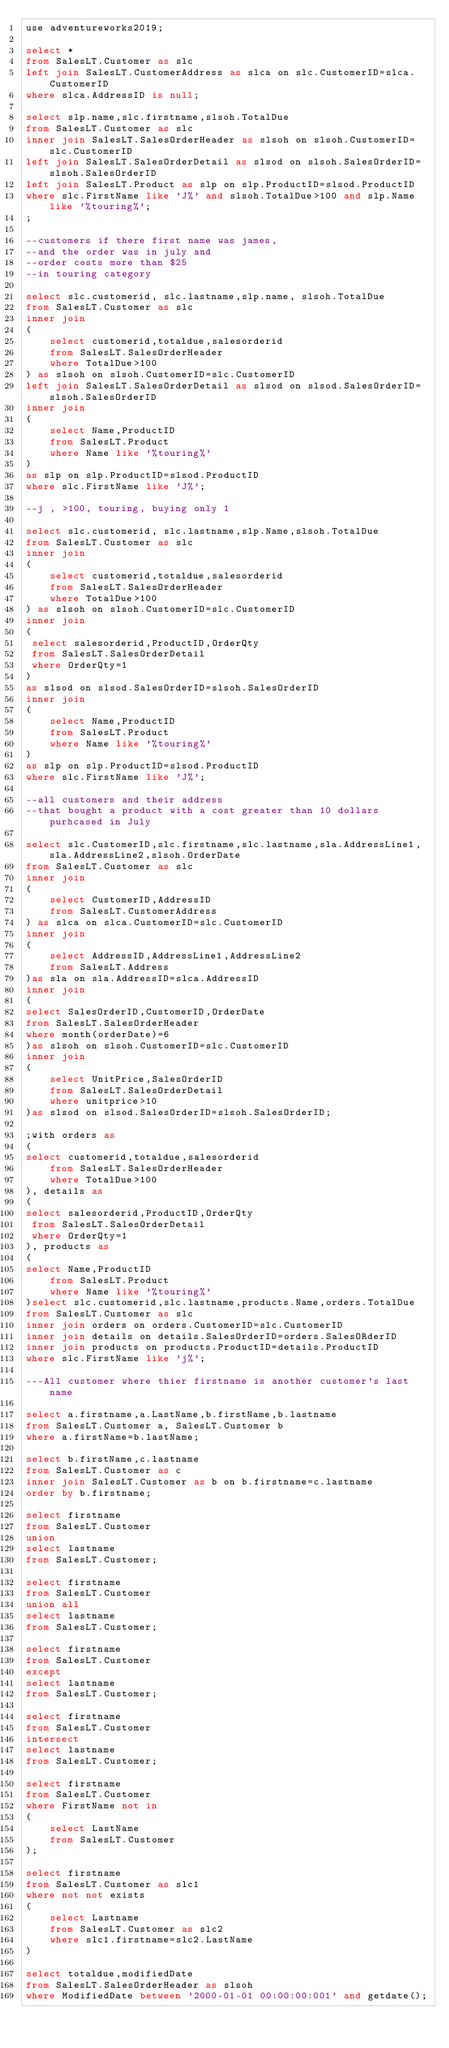Convert code to text. <code><loc_0><loc_0><loc_500><loc_500><_SQL_>use adventureworks2019;

select *
from SalesLT.Customer as slc
left join SalesLT.CustomerAddress as slca on slc.CustomerID=slca.CustomerID
where slca.AddressID is null;

select slp.name,slc.firstname,slsoh.TotalDue
from SalesLT.Customer as slc
inner join SalesLT.SalesOrderHeader as slsoh on slsoh.CustomerID=slc.CustomerID
left join SalesLT.SalesOrderDetail as slsod on slsoh.SalesOrderID=slsoh.SalesOrderID
left join SalesLT.Product as slp on slp.ProductID=slsod.ProductID
where slc.FirstName like 'J%' and slsoh.TotalDue>100 and slp.Name like '%touring%';
;

--customers if there first name was james,
--and the order was in july and 
--order costs more than $25
--in touring category

select slc.customerid, slc.lastname,slp.name, slsoh.TotalDue
from SalesLT.Customer as slc
inner join
(
	select customerid,totaldue,salesorderid
	from SalesLT.SalesOrderHeader
	where TotalDue>100
) as slsoh on slsoh.CustomerID=slc.CustomerID
left join SalesLT.SalesOrderDetail as slsod on slsod.SalesOrderID=slsoh.SalesOrderID
inner join
(
	select Name,ProductID
	from SalesLT.Product
	where Name like '%touring%'
)
as slp on slp.ProductID=slsod.ProductID
where slc.FirstName like 'J%';

--j , >100, touring, buying only 1

select slc.customerid, slc.lastname,slp.Name,slsoh.TotalDue
from SalesLT.Customer as slc
inner join
(
	select customerid,totaldue,salesorderid
	from SalesLT.SalesOrderHeader
	where TotalDue>100
) as slsoh on slsoh.CustomerID=slc.CustomerID
inner join
(
 select salesorderid,ProductID,OrderQty
 from SalesLT.SalesOrderDetail
 where OrderQty=1 
) 
as slsod on slsod.SalesOrderID=slsoh.SalesOrderID
inner join
(
	select Name,ProductID
	from SalesLT.Product
	where Name like '%touring%'
)
as slp on slp.ProductID=slsod.ProductID
where slc.FirstName like 'J%';

--all customers and their address
--that bought a product with a cost greater than 10 dollars purhcased in July

select slc.CustomerID,slc.firstname,slc.lastname,sla.AddressLine1,sla.AddressLine2,slsoh.OrderDate
from SalesLT.Customer as slc
inner join
(
	select CustomerID,AddressID
	from SalesLT.CustomerAddress 
) as slca on slca.CustomerID=slc.CustomerID
inner join
(
	select AddressID,AddressLine1,AddressLine2
	from SalesLT.Address
)as sla on sla.AddressID=slca.AddressID
inner join
(
select SalesOrderID,CustomerID,OrderDate
from SalesLT.SalesOrderHeader
where month(orderDate)=6
)as slsoh on slsoh.CustomerID=slc.CustomerID
inner join
(
	select UnitPrice,SalesOrderID
	from SalesLT.SalesOrderDetail
	where unitprice>10
)as slsod on slsod.SalesOrderID=slsoh.SalesOrderID;

;with orders as
(
select customerid,totaldue,salesorderid
	from SalesLT.SalesOrderHeader
	where TotalDue>100
), details as
(
select salesorderid,ProductID,OrderQty
 from SalesLT.SalesOrderDetail
 where OrderQty=1 
), products as
(
select Name,ProductID
	from SalesLT.Product
	where Name like '%touring%'
)select slc.customerid,slc.lastname,products.Name,orders.TotalDue
from SalesLT.Customer as slc
inner join orders on orders.CustomerID=slc.CustomerID
inner join details on details.SalesOrderID=orders.SalesORderID
inner join products on products.ProductID=details.ProductID
where slc.FirstName like 'j%';

---All customer where thier firstname is another customer's last name

select a.firstname,a.LastName,b.firstName,b.lastname
from SalesLT.Customer a, SalesLT.Customer b
where a.firstName=b.lastName;

select b.firstName,c.lastname
from SalesLT.Customer as c
inner join SalesLT.Customer as b on b.firstname=c.lastname
order by b.firstname;

select firstname
from SalesLT.Customer
union
select lastname
from SalesLT.Customer;

select firstname
from SalesLT.Customer
union all
select lastname
from SalesLT.Customer;

select firstname
from SalesLT.Customer
except
select lastname
from SalesLT.Customer;

select firstname
from SalesLT.Customer
intersect
select lastname
from SalesLT.Customer;

select firstname
from SalesLT.Customer
where FirstName not in
(
	select LastName
	from SalesLT.Customer
);

select firstname
from SalesLT.Customer as slc1
where not not exists
(
	select Lastname
	from SalesLT.Customer as slc2
	where slc1.firstname=slc2.LastName
)

select totaldue,modifiedDate
from SalesLT.SalesOrderHeader as slsoh
where ModifiedDate between '2000-01-01 00:00:00:001' and getdate();</code> 